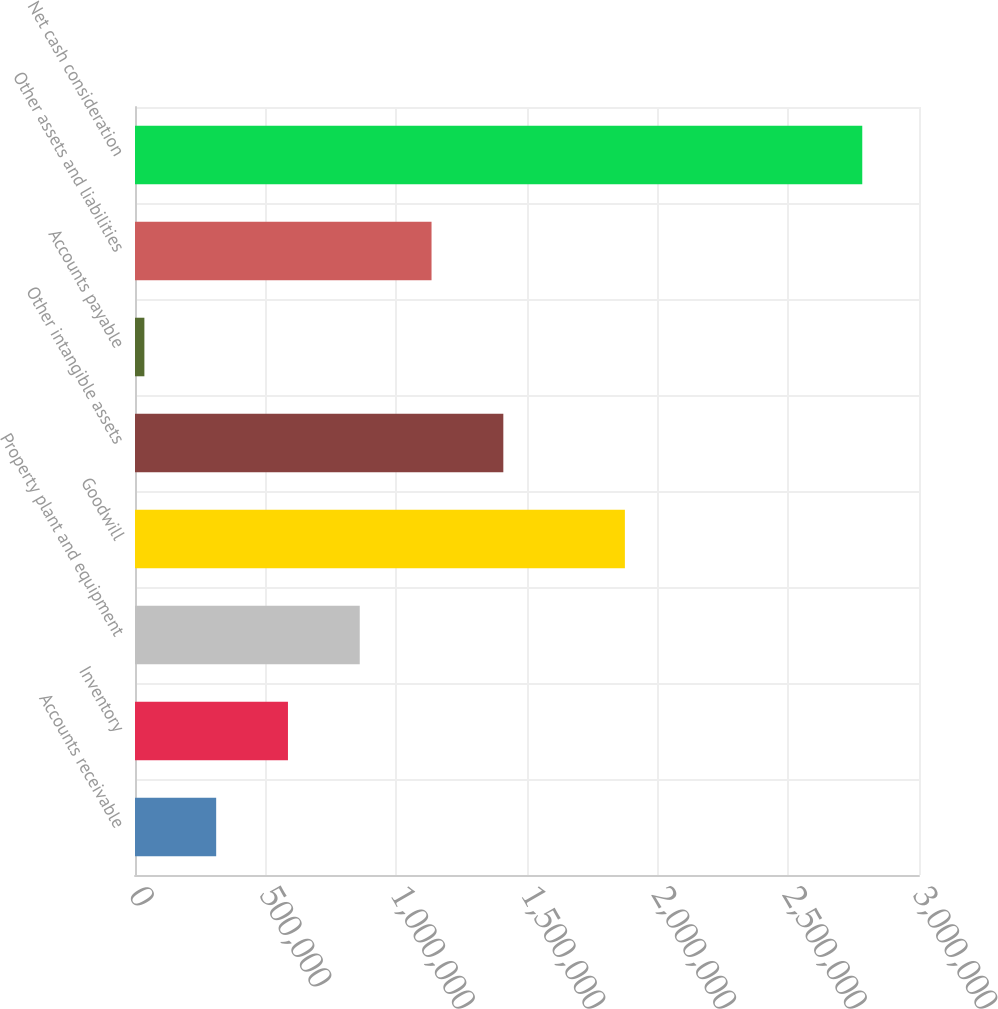Convert chart to OTSL. <chart><loc_0><loc_0><loc_500><loc_500><bar_chart><fcel>Accounts receivable<fcel>Inventory<fcel>Property plant and equipment<fcel>Goodwill<fcel>Other intangible assets<fcel>Accounts payable<fcel>Other assets and liabilities<fcel>Net cash consideration<nl><fcel>310616<fcel>585313<fcel>860010<fcel>1.87458e+06<fcel>1.4094e+06<fcel>35919<fcel>1.13471e+06<fcel>2.78289e+06<nl></chart> 